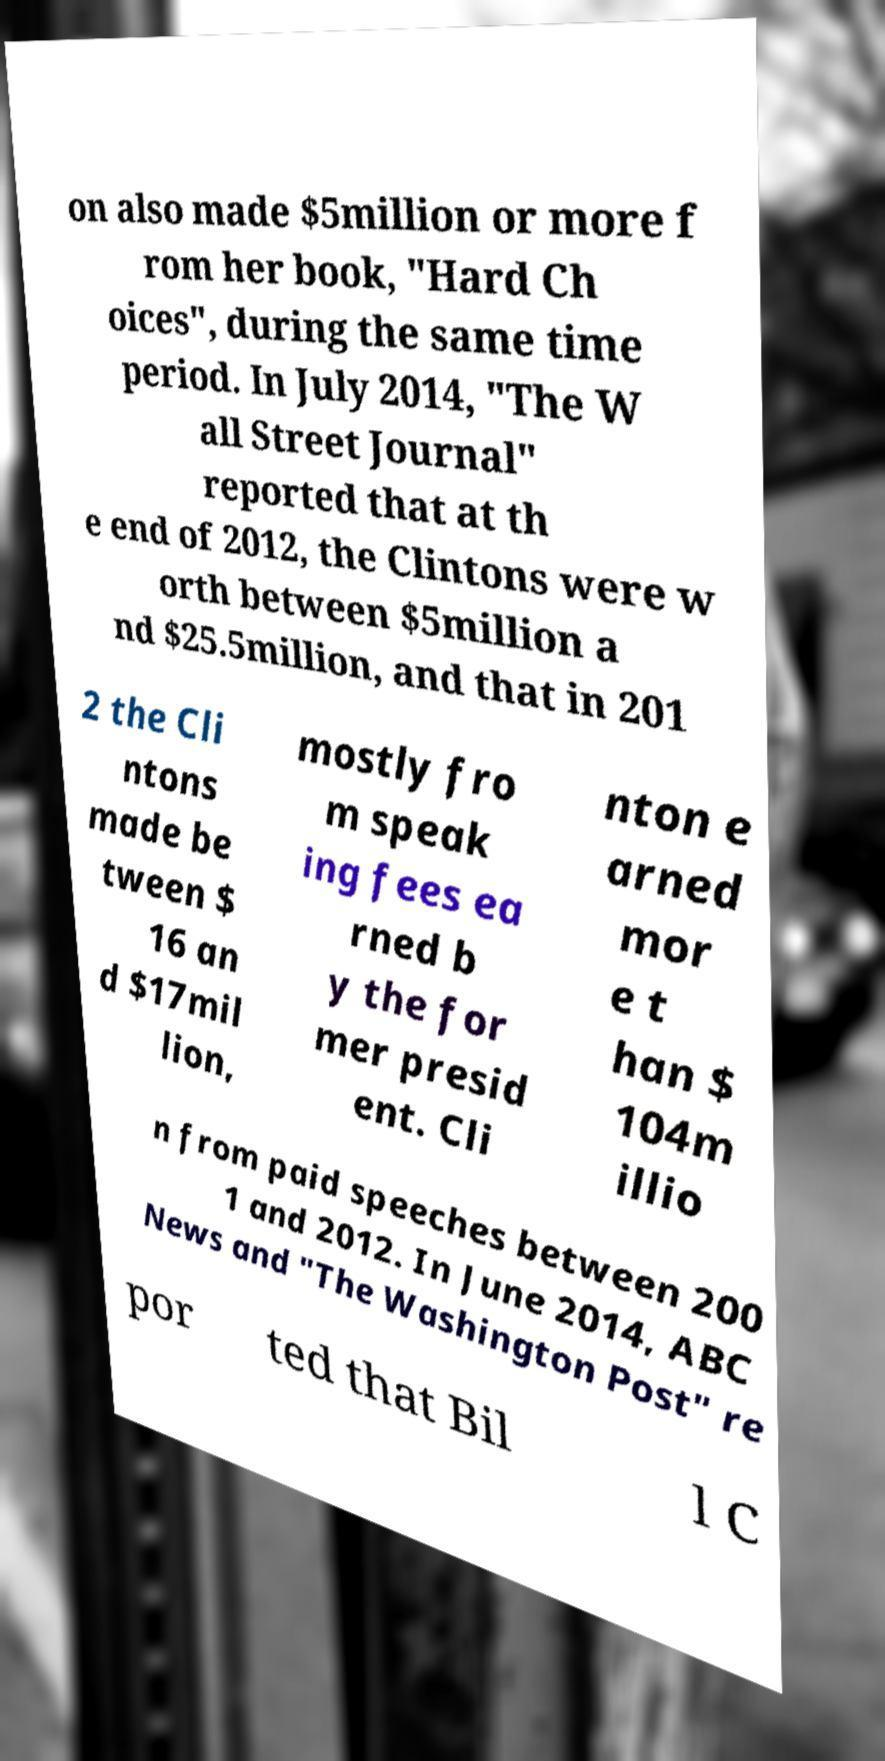I need the written content from this picture converted into text. Can you do that? on also made $5million or more f rom her book, "Hard Ch oices", during the same time period. In July 2014, "The W all Street Journal" reported that at th e end of 2012, the Clintons were w orth between $5million a nd $25.5million, and that in 201 2 the Cli ntons made be tween $ 16 an d $17mil lion, mostly fro m speak ing fees ea rned b y the for mer presid ent. Cli nton e arned mor e t han $ 104m illio n from paid speeches between 200 1 and 2012. In June 2014, ABC News and "The Washington Post" re por ted that Bil l C 